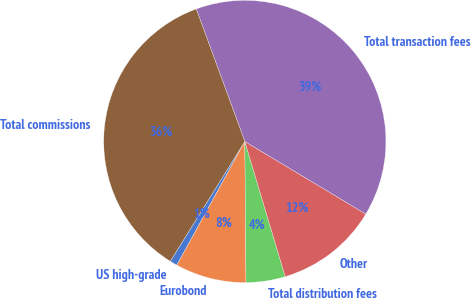Convert chart. <chart><loc_0><loc_0><loc_500><loc_500><pie_chart><fcel>US high-grade<fcel>Eurobond<fcel>Total distribution fees<fcel>Other<fcel>Total transaction fees<fcel>Total commissions<nl><fcel>0.86%<fcel>8.13%<fcel>4.49%<fcel>11.77%<fcel>39.19%<fcel>35.55%<nl></chart> 